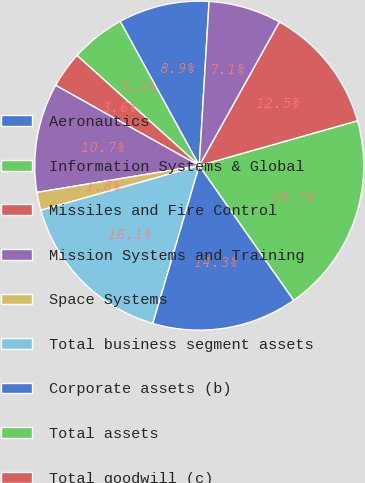Convert chart. <chart><loc_0><loc_0><loc_500><loc_500><pie_chart><fcel>Aeronautics<fcel>Information Systems & Global<fcel>Missiles and Fire Control<fcel>Mission Systems and Training<fcel>Space Systems<fcel>Total business segment assets<fcel>Corporate assets (b)<fcel>Total assets<fcel>Total goodwill (c)<fcel>Total customer advances and<nl><fcel>8.93%<fcel>5.35%<fcel>3.56%<fcel>10.72%<fcel>1.77%<fcel>16.08%<fcel>14.29%<fcel>19.66%<fcel>12.51%<fcel>7.14%<nl></chart> 